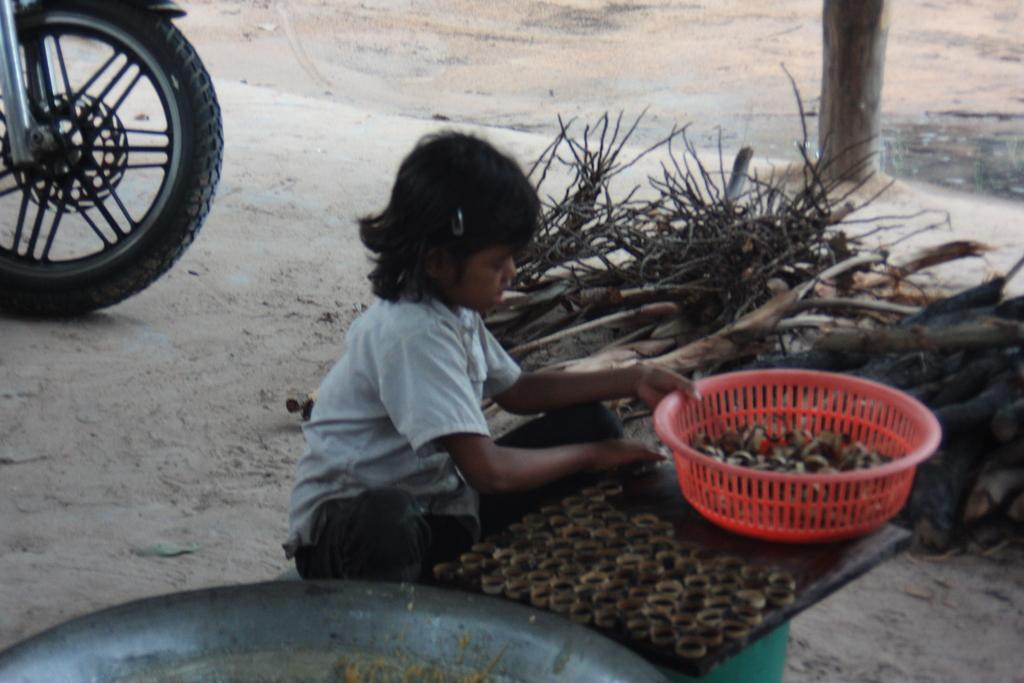Who is the main subject in the image? There is a girl in the image. What is in front of the girl? There are objects in front of the girl. What type of material can be seen in the image? There are wooden sticks visible in the image. What part of a motorbike can be seen in the image? There is a motorbike wheel in the image. What muscle is the girl exercising in the image? There is no indication of the girl exercising or using any specific muscle in the image. 